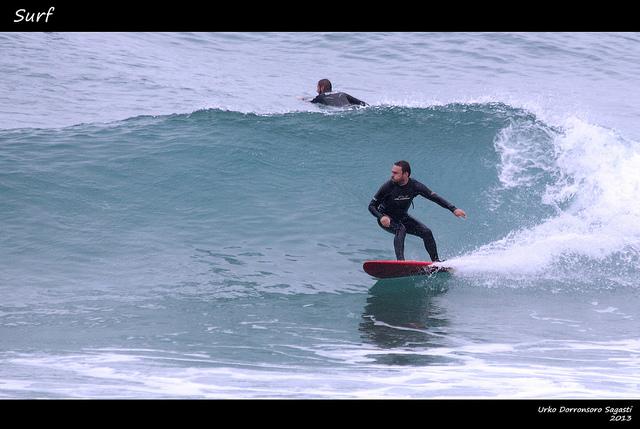How big is the wave?
Answer briefly. Small. After this activity will the person be wet?
Quick response, please. Yes. What color is the surfboard?
Short answer required. Red. Is this man athletic?
Be succinct. Yes. Are there waves in the water?
Concise answer only. Yes. 